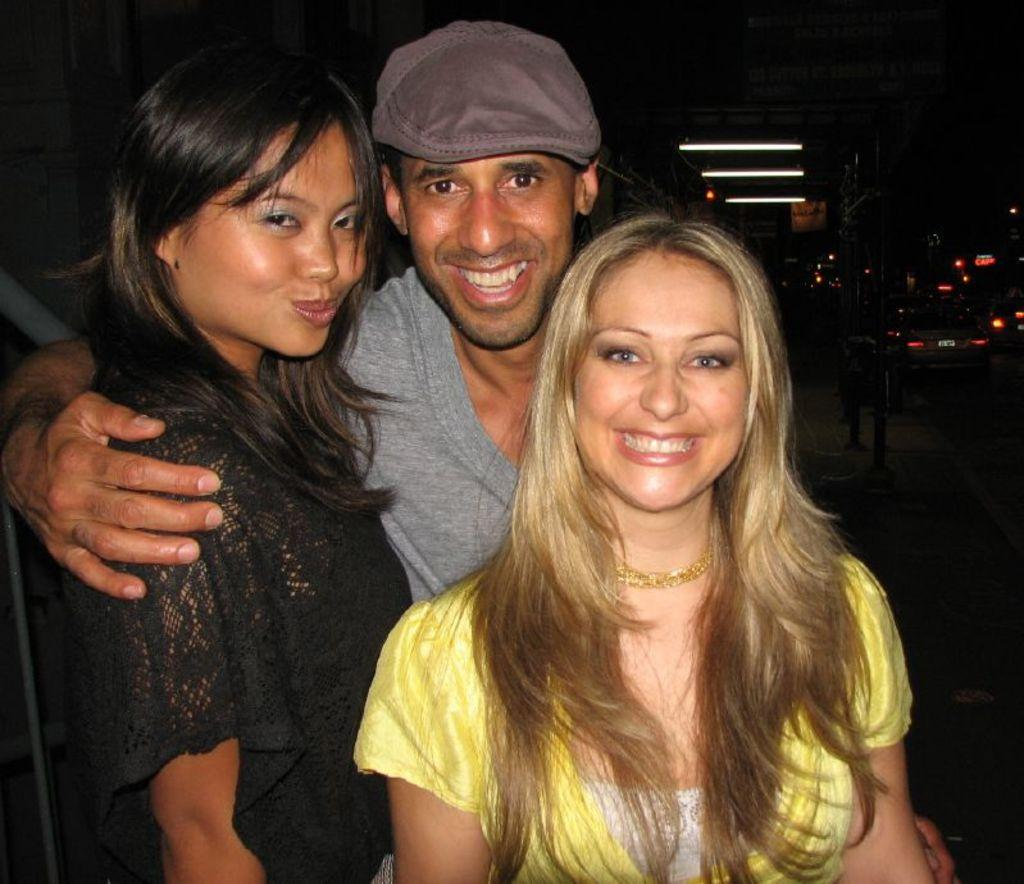How many people are in the image? There are three people in the image. What are the people doing in the image? The people are posing for a photo. What can be seen in the background of the image? There are vehicles moving on the road in the background. Where are the people standing in the image? The people are standing on a footpath. What type of collar is the duck wearing in the image? There is no duck present in the image, and therefore no collar can be observed. 